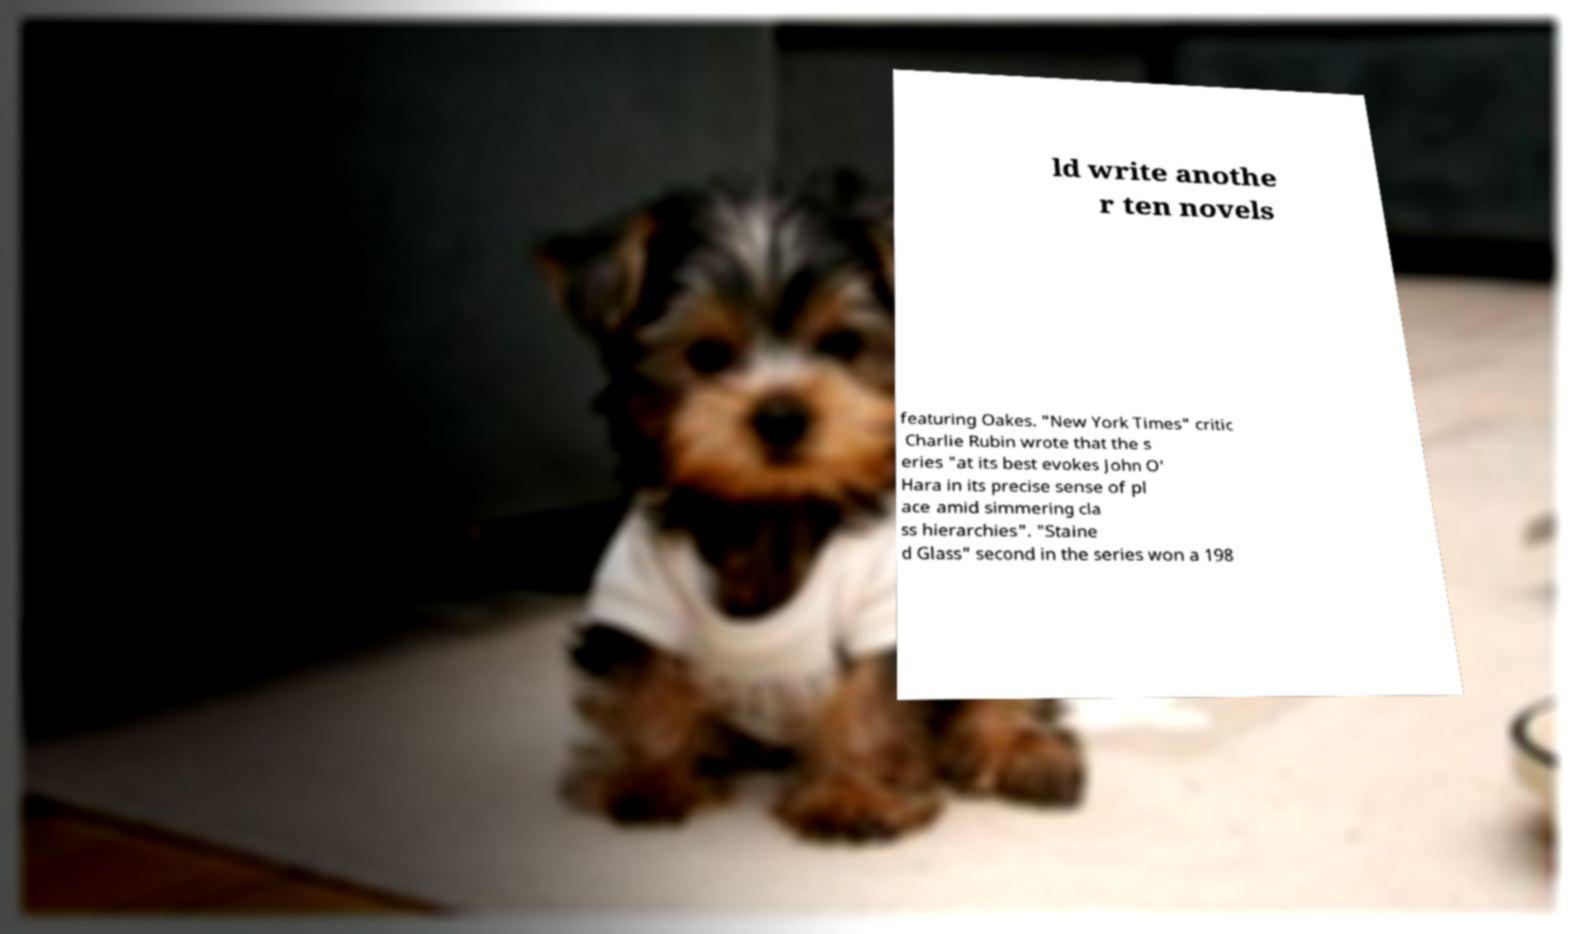What messages or text are displayed in this image? I need them in a readable, typed format. ld write anothe r ten novels featuring Oakes. "New York Times" critic Charlie Rubin wrote that the s eries "at its best evokes John O' Hara in its precise sense of pl ace amid simmering cla ss hierarchies". "Staine d Glass" second in the series won a 198 